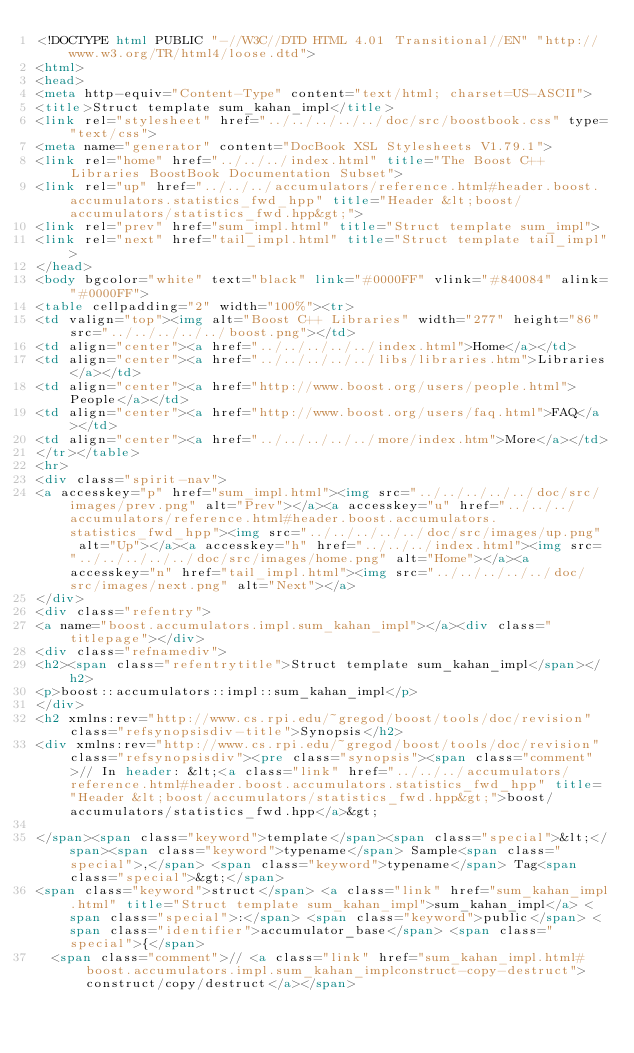<code> <loc_0><loc_0><loc_500><loc_500><_HTML_><!DOCTYPE html PUBLIC "-//W3C//DTD HTML 4.01 Transitional//EN" "http://www.w3.org/TR/html4/loose.dtd">
<html>
<head>
<meta http-equiv="Content-Type" content="text/html; charset=US-ASCII">
<title>Struct template sum_kahan_impl</title>
<link rel="stylesheet" href="../../../../../doc/src/boostbook.css" type="text/css">
<meta name="generator" content="DocBook XSL Stylesheets V1.79.1">
<link rel="home" href="../../../index.html" title="The Boost C++ Libraries BoostBook Documentation Subset">
<link rel="up" href="../../../accumulators/reference.html#header.boost.accumulators.statistics_fwd_hpp" title="Header &lt;boost/accumulators/statistics_fwd.hpp&gt;">
<link rel="prev" href="sum_impl.html" title="Struct template sum_impl">
<link rel="next" href="tail_impl.html" title="Struct template tail_impl">
</head>
<body bgcolor="white" text="black" link="#0000FF" vlink="#840084" alink="#0000FF">
<table cellpadding="2" width="100%"><tr>
<td valign="top"><img alt="Boost C++ Libraries" width="277" height="86" src="../../../../../boost.png"></td>
<td align="center"><a href="../../../../../index.html">Home</a></td>
<td align="center"><a href="../../../../../libs/libraries.htm">Libraries</a></td>
<td align="center"><a href="http://www.boost.org/users/people.html">People</a></td>
<td align="center"><a href="http://www.boost.org/users/faq.html">FAQ</a></td>
<td align="center"><a href="../../../../../more/index.htm">More</a></td>
</tr></table>
<hr>
<div class="spirit-nav">
<a accesskey="p" href="sum_impl.html"><img src="../../../../../doc/src/images/prev.png" alt="Prev"></a><a accesskey="u" href="../../../accumulators/reference.html#header.boost.accumulators.statistics_fwd_hpp"><img src="../../../../../doc/src/images/up.png" alt="Up"></a><a accesskey="h" href="../../../index.html"><img src="../../../../../doc/src/images/home.png" alt="Home"></a><a accesskey="n" href="tail_impl.html"><img src="../../../../../doc/src/images/next.png" alt="Next"></a>
</div>
<div class="refentry">
<a name="boost.accumulators.impl.sum_kahan_impl"></a><div class="titlepage"></div>
<div class="refnamediv">
<h2><span class="refentrytitle">Struct template sum_kahan_impl</span></h2>
<p>boost::accumulators::impl::sum_kahan_impl</p>
</div>
<h2 xmlns:rev="http://www.cs.rpi.edu/~gregod/boost/tools/doc/revision" class="refsynopsisdiv-title">Synopsis</h2>
<div xmlns:rev="http://www.cs.rpi.edu/~gregod/boost/tools/doc/revision" class="refsynopsisdiv"><pre class="synopsis"><span class="comment">// In header: &lt;<a class="link" href="../../../accumulators/reference.html#header.boost.accumulators.statistics_fwd_hpp" title="Header &lt;boost/accumulators/statistics_fwd.hpp&gt;">boost/accumulators/statistics_fwd.hpp</a>&gt;

</span><span class="keyword">template</span><span class="special">&lt;</span><span class="keyword">typename</span> Sample<span class="special">,</span> <span class="keyword">typename</span> Tag<span class="special">&gt;</span> 
<span class="keyword">struct</span> <a class="link" href="sum_kahan_impl.html" title="Struct template sum_kahan_impl">sum_kahan_impl</a> <span class="special">:</span> <span class="keyword">public</span> <span class="identifier">accumulator_base</span> <span class="special">{</span>
  <span class="comment">// <a class="link" href="sum_kahan_impl.html#boost.accumulators.impl.sum_kahan_implconstruct-copy-destruct">construct/copy/destruct</a></span></code> 